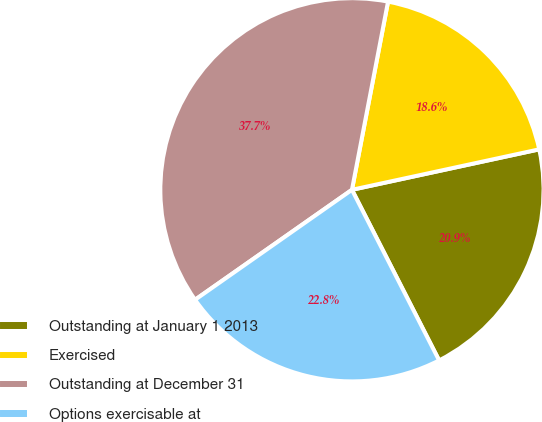Convert chart to OTSL. <chart><loc_0><loc_0><loc_500><loc_500><pie_chart><fcel>Outstanding at January 1 2013<fcel>Exercised<fcel>Outstanding at December 31<fcel>Options exercisable at<nl><fcel>20.87%<fcel>18.6%<fcel>37.75%<fcel>22.79%<nl></chart> 